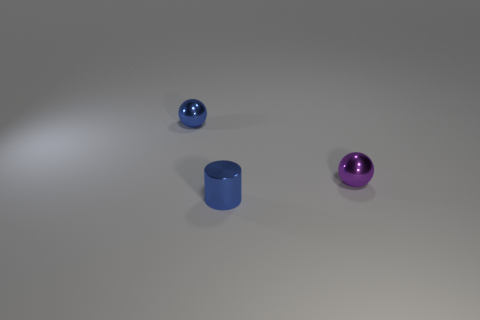Subtract all blue spheres. How many spheres are left? 1 Add 2 tiny cylinders. How many objects exist? 5 Subtract 0 yellow spheres. How many objects are left? 3 Subtract all cylinders. How many objects are left? 2 Subtract 1 balls. How many balls are left? 1 Subtract all brown cylinders. Subtract all blue spheres. How many cylinders are left? 1 Subtract all yellow balls. How many purple cylinders are left? 0 Subtract all gray metallic spheres. Subtract all blue metallic objects. How many objects are left? 1 Add 3 purple balls. How many purple balls are left? 4 Add 1 tiny brown things. How many tiny brown things exist? 1 